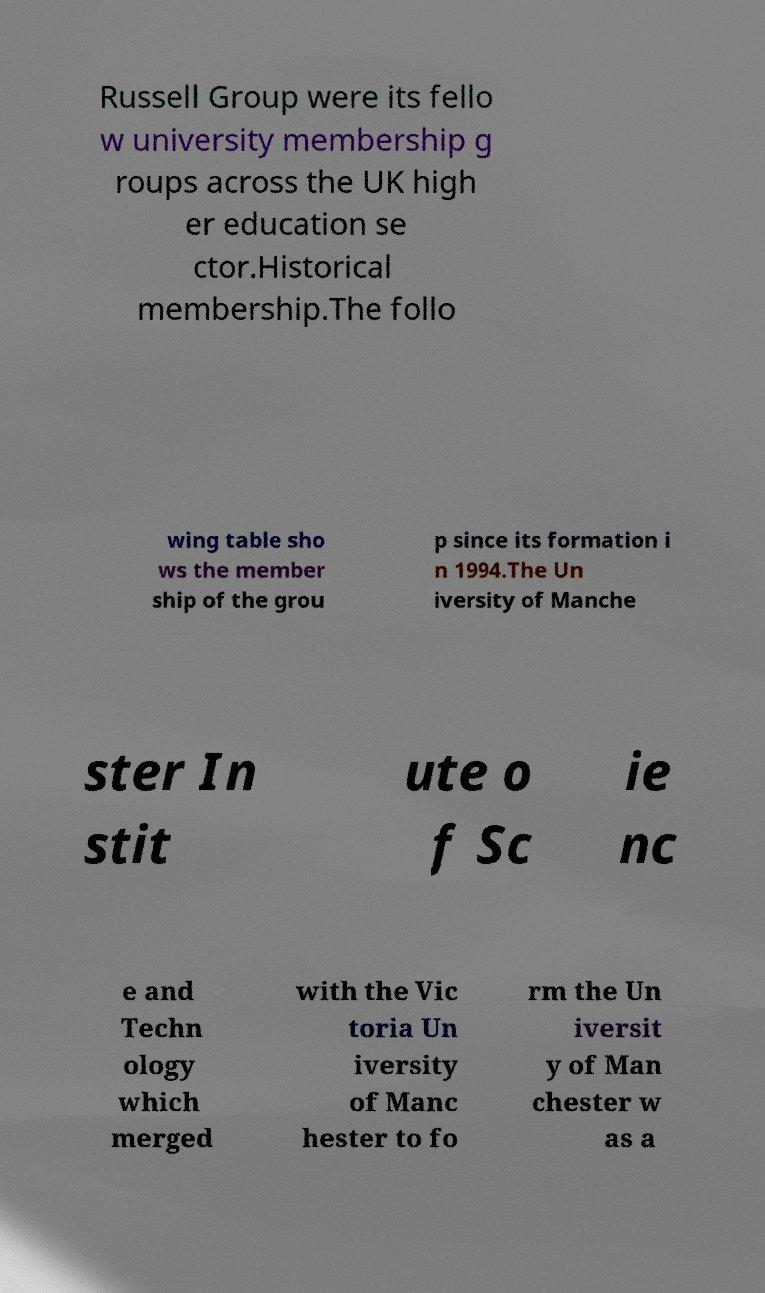Could you assist in decoding the text presented in this image and type it out clearly? Russell Group were its fello w university membership g roups across the UK high er education se ctor.Historical membership.The follo wing table sho ws the member ship of the grou p since its formation i n 1994.The Un iversity of Manche ster In stit ute o f Sc ie nc e and Techn ology which merged with the Vic toria Un iversity of Manc hester to fo rm the Un iversit y of Man chester w as a 